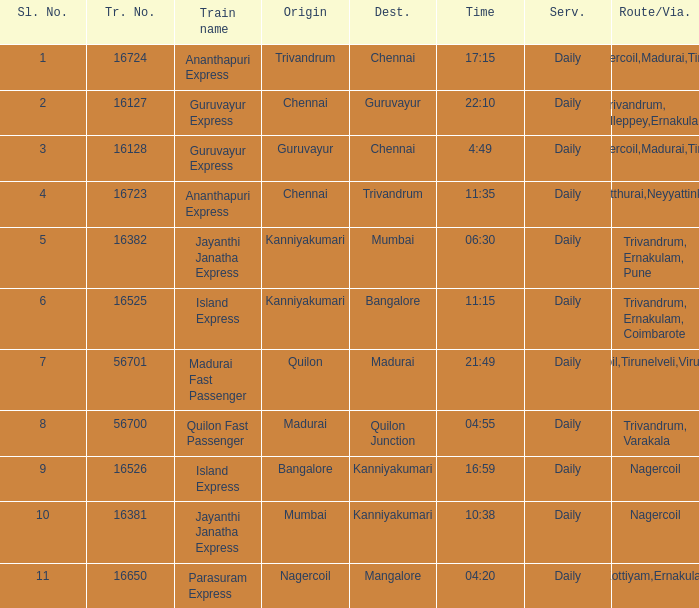What is the origin when the destination is Mumbai? Kanniyakumari. 